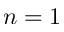Convert formula to latex. <formula><loc_0><loc_0><loc_500><loc_500>n = 1</formula> 